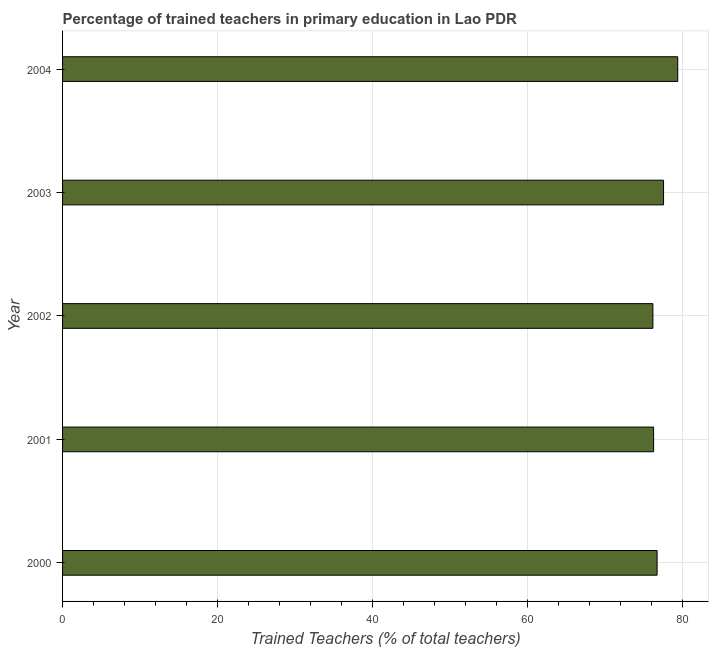Does the graph contain any zero values?
Offer a terse response. No. What is the title of the graph?
Keep it short and to the point. Percentage of trained teachers in primary education in Lao PDR. What is the label or title of the X-axis?
Offer a very short reply. Trained Teachers (% of total teachers). What is the label or title of the Y-axis?
Ensure brevity in your answer.  Year. What is the percentage of trained teachers in 2000?
Your answer should be very brief. 76.69. Across all years, what is the maximum percentage of trained teachers?
Offer a terse response. 79.35. Across all years, what is the minimum percentage of trained teachers?
Ensure brevity in your answer.  76.15. What is the sum of the percentage of trained teachers?
Make the answer very short. 385.96. What is the difference between the percentage of trained teachers in 2000 and 2002?
Ensure brevity in your answer.  0.54. What is the average percentage of trained teachers per year?
Provide a short and direct response. 77.19. What is the median percentage of trained teachers?
Your response must be concise. 76.69. Do a majority of the years between 2000 and 2004 (inclusive) have percentage of trained teachers greater than 68 %?
Keep it short and to the point. Yes. Is the percentage of trained teachers in 2002 less than that in 2004?
Make the answer very short. Yes. What is the difference between the highest and the second highest percentage of trained teachers?
Your response must be concise. 1.83. What is the difference between the highest and the lowest percentage of trained teachers?
Offer a very short reply. 3.2. How many bars are there?
Give a very brief answer. 5. What is the difference between two consecutive major ticks on the X-axis?
Your response must be concise. 20. Are the values on the major ticks of X-axis written in scientific E-notation?
Your answer should be very brief. No. What is the Trained Teachers (% of total teachers) of 2000?
Ensure brevity in your answer.  76.69. What is the Trained Teachers (% of total teachers) in 2001?
Provide a short and direct response. 76.24. What is the Trained Teachers (% of total teachers) in 2002?
Your response must be concise. 76.15. What is the Trained Teachers (% of total teachers) in 2003?
Your response must be concise. 77.52. What is the Trained Teachers (% of total teachers) in 2004?
Provide a short and direct response. 79.35. What is the difference between the Trained Teachers (% of total teachers) in 2000 and 2001?
Keep it short and to the point. 0.45. What is the difference between the Trained Teachers (% of total teachers) in 2000 and 2002?
Provide a succinct answer. 0.54. What is the difference between the Trained Teachers (% of total teachers) in 2000 and 2003?
Provide a short and direct response. -0.83. What is the difference between the Trained Teachers (% of total teachers) in 2000 and 2004?
Offer a very short reply. -2.66. What is the difference between the Trained Teachers (% of total teachers) in 2001 and 2002?
Your answer should be compact. 0.09. What is the difference between the Trained Teachers (% of total teachers) in 2001 and 2003?
Keep it short and to the point. -1.28. What is the difference between the Trained Teachers (% of total teachers) in 2001 and 2004?
Ensure brevity in your answer.  -3.11. What is the difference between the Trained Teachers (% of total teachers) in 2002 and 2003?
Provide a short and direct response. -1.37. What is the difference between the Trained Teachers (% of total teachers) in 2002 and 2004?
Your response must be concise. -3.2. What is the difference between the Trained Teachers (% of total teachers) in 2003 and 2004?
Provide a succinct answer. -1.83. What is the ratio of the Trained Teachers (% of total teachers) in 2000 to that in 2004?
Your answer should be very brief. 0.97. What is the ratio of the Trained Teachers (% of total teachers) in 2001 to that in 2002?
Provide a succinct answer. 1. What is the ratio of the Trained Teachers (% of total teachers) in 2001 to that in 2003?
Keep it short and to the point. 0.98. What is the ratio of the Trained Teachers (% of total teachers) in 2002 to that in 2003?
Keep it short and to the point. 0.98. 